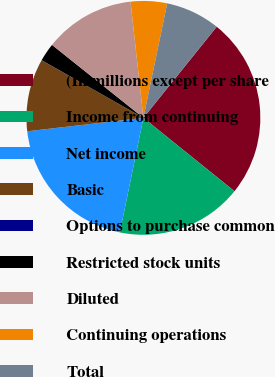Convert chart. <chart><loc_0><loc_0><loc_500><loc_500><pie_chart><fcel>(In millions except per share<fcel>Income from continuing<fcel>Net income<fcel>Basic<fcel>Options to purchase common<fcel>Restricted stock units<fcel>Diluted<fcel>Continuing operations<fcel>Total<nl><fcel>25.01%<fcel>17.44%<fcel>19.94%<fcel>10.02%<fcel>0.02%<fcel>2.52%<fcel>12.52%<fcel>5.02%<fcel>7.52%<nl></chart> 